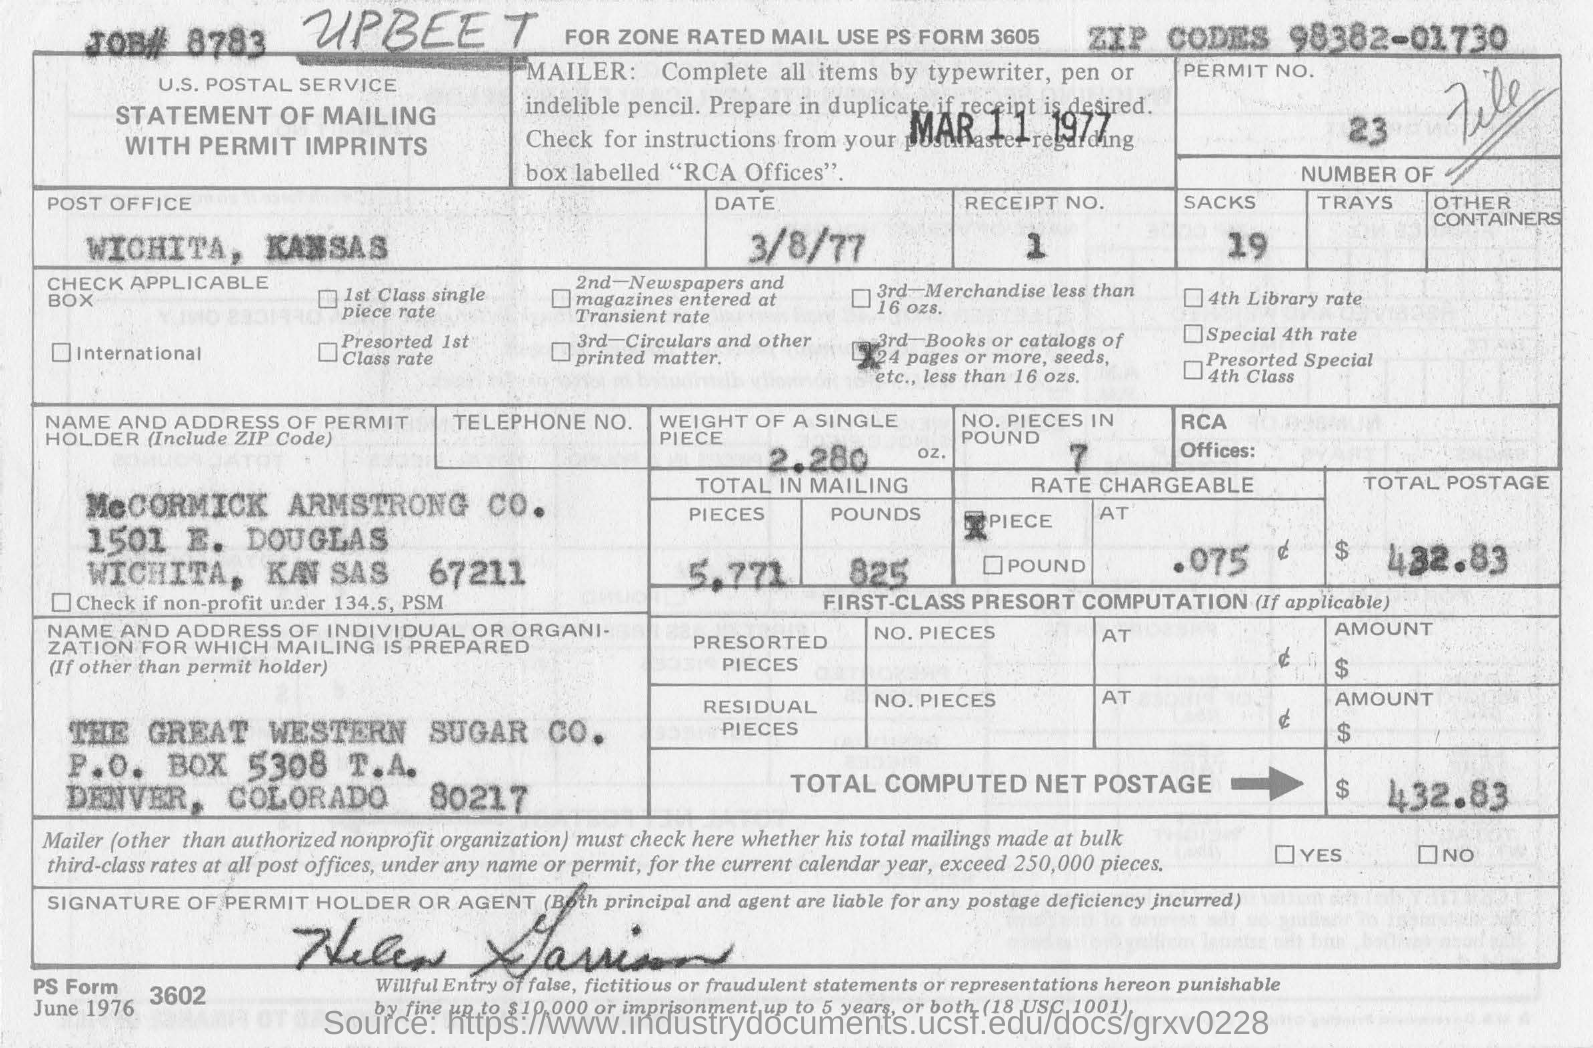Give some essential details in this illustration. The total computed net postage is $432.83. The permit holder is McCormick Armstrong Company. The permit number is 23. The weight of a single piece is 2.280 ounces. The form is from the post office in Wichita, Kansas. 